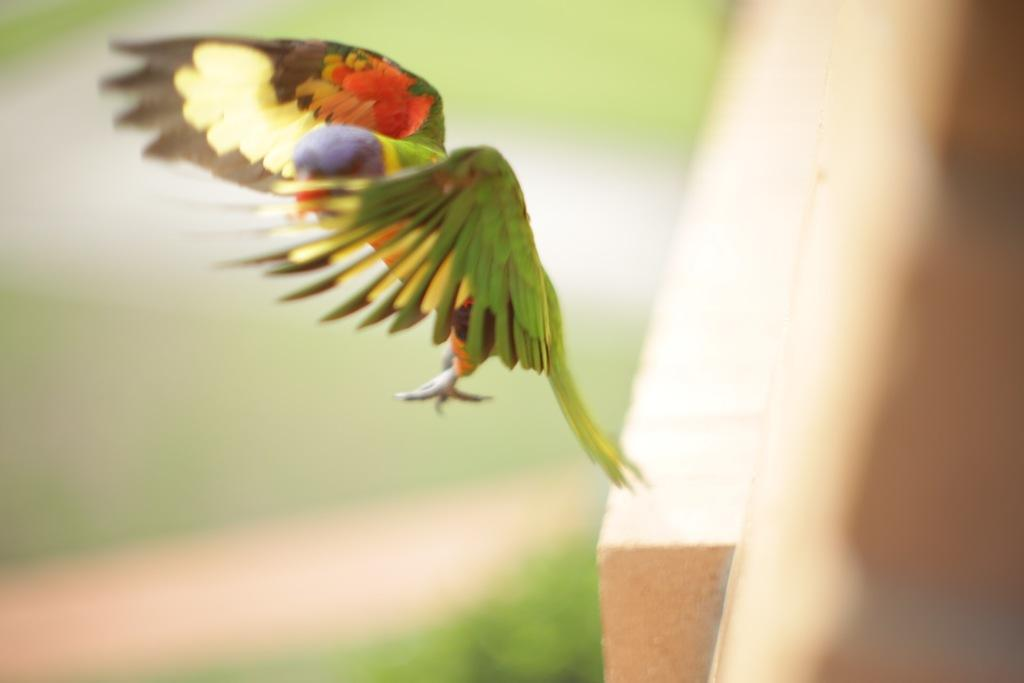What type of animal is in the image? There is a parrot in the image. Can you describe the background of the image? The background of the image is blurred. What type of lunch is the parrot eating in the image? There is no lunch present in the image, as it only features a parrot and a blurred background. 